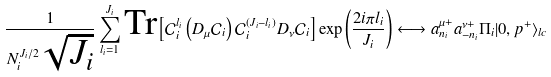Convert formula to latex. <formula><loc_0><loc_0><loc_500><loc_500>\frac { 1 } { N _ { i } ^ { J _ { i } / 2 } \sqrt { J _ { i } } } \sum _ { l _ { i } = 1 } ^ { J _ { i } } \text {Tr} \left [ \mathcal { C } _ { i } ^ { l _ { i } } \left ( D _ { \mu } \mathcal { C } _ { i } \right ) \mathcal { C } _ { i } ^ { ( J _ { i } - l _ { i } ) } D _ { \nu } \mathcal { C } _ { i } \right ] \exp \left ( \frac { 2 i \pi l _ { i } } { J _ { i } } \right ) \longleftrightarrow a _ { n _ { i } } ^ { \mu + } a _ { - n _ { i } } ^ { \nu + } \Pi _ { i } | 0 , p ^ { + } \rangle _ { l c }</formula> 